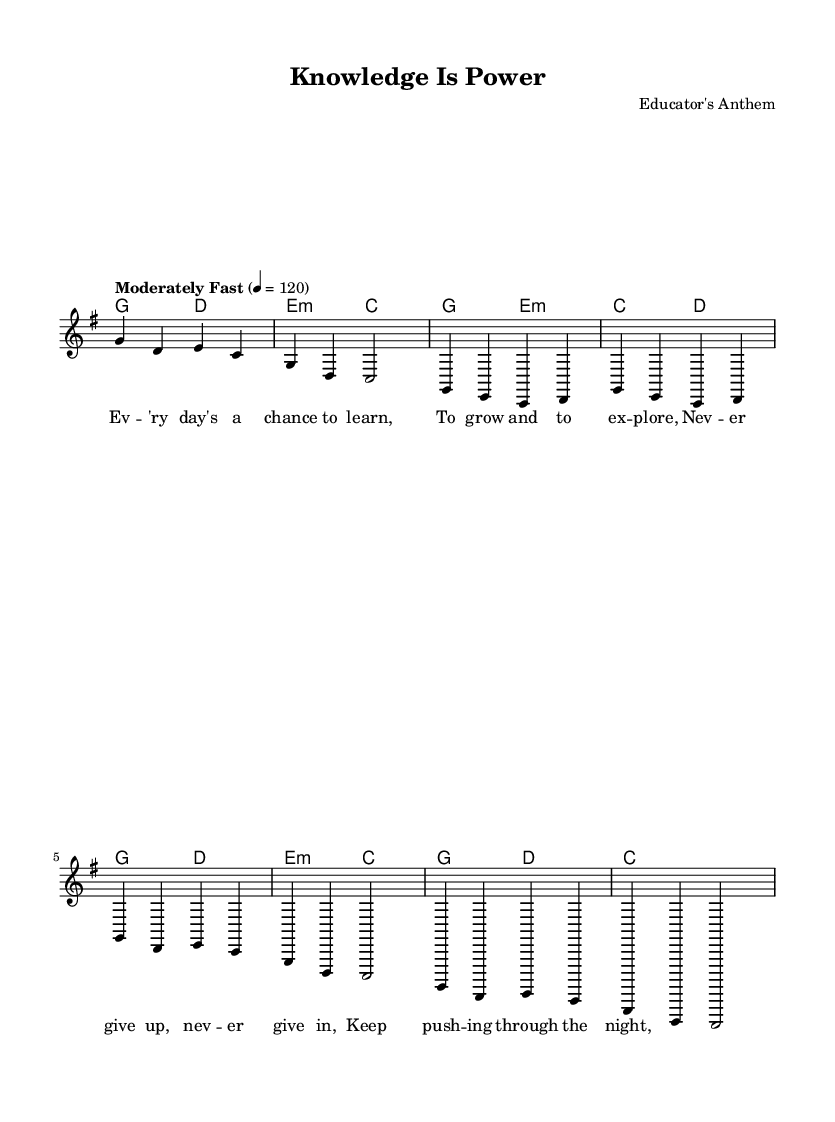What is the key signature of this music? The key signature is G major, which has one sharp (F#). You can determine the key signature by looking at the beginning of the staff where it shows the number of sharps or flats; here, there is one sharp indicating G major.
Answer: G major What is the time signature of this music? The time signature is 4/4, which can be found at the beginning of the score, indicating that there are four beats per measure and the quarter note gets one beat.
Answer: 4/4 What is the tempo marking for this song? The tempo marking is "Moderately Fast," followed by a metronome mark of 120 beats per minute. This indicates the pace at which the piece should be played.
Answer: Moderately Fast How many measures are in the chorus section? The chorus consists of 4 measures as seen in the repeated section indicated in the music. By counting the measures, you can see that there are four distinct groupings.
Answer: 4 What type of chord follows the G major chord in the verses? The chord that follows the G major chord is E minor, which can be found in the harmonies part of the sheet music where the chord progression lists G major followed by E minor.
Answer: E minor How many times does the phrase "never give up" appear in the lyrics? The phrase "never give up" appears twice in the lyrics, as you analyze the text written below the notes in the verse section of the sheet music.
Answer: 2 